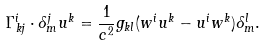Convert formula to latex. <formula><loc_0><loc_0><loc_500><loc_500>\Gamma _ { k j } ^ { i } \cdot \delta _ { m } ^ { j } u ^ { k } = \frac { 1 } { c ^ { 2 } } g _ { k l } ( w ^ { i } u ^ { k } - u ^ { i } w ^ { k } ) \delta _ { m } ^ { l } .</formula> 